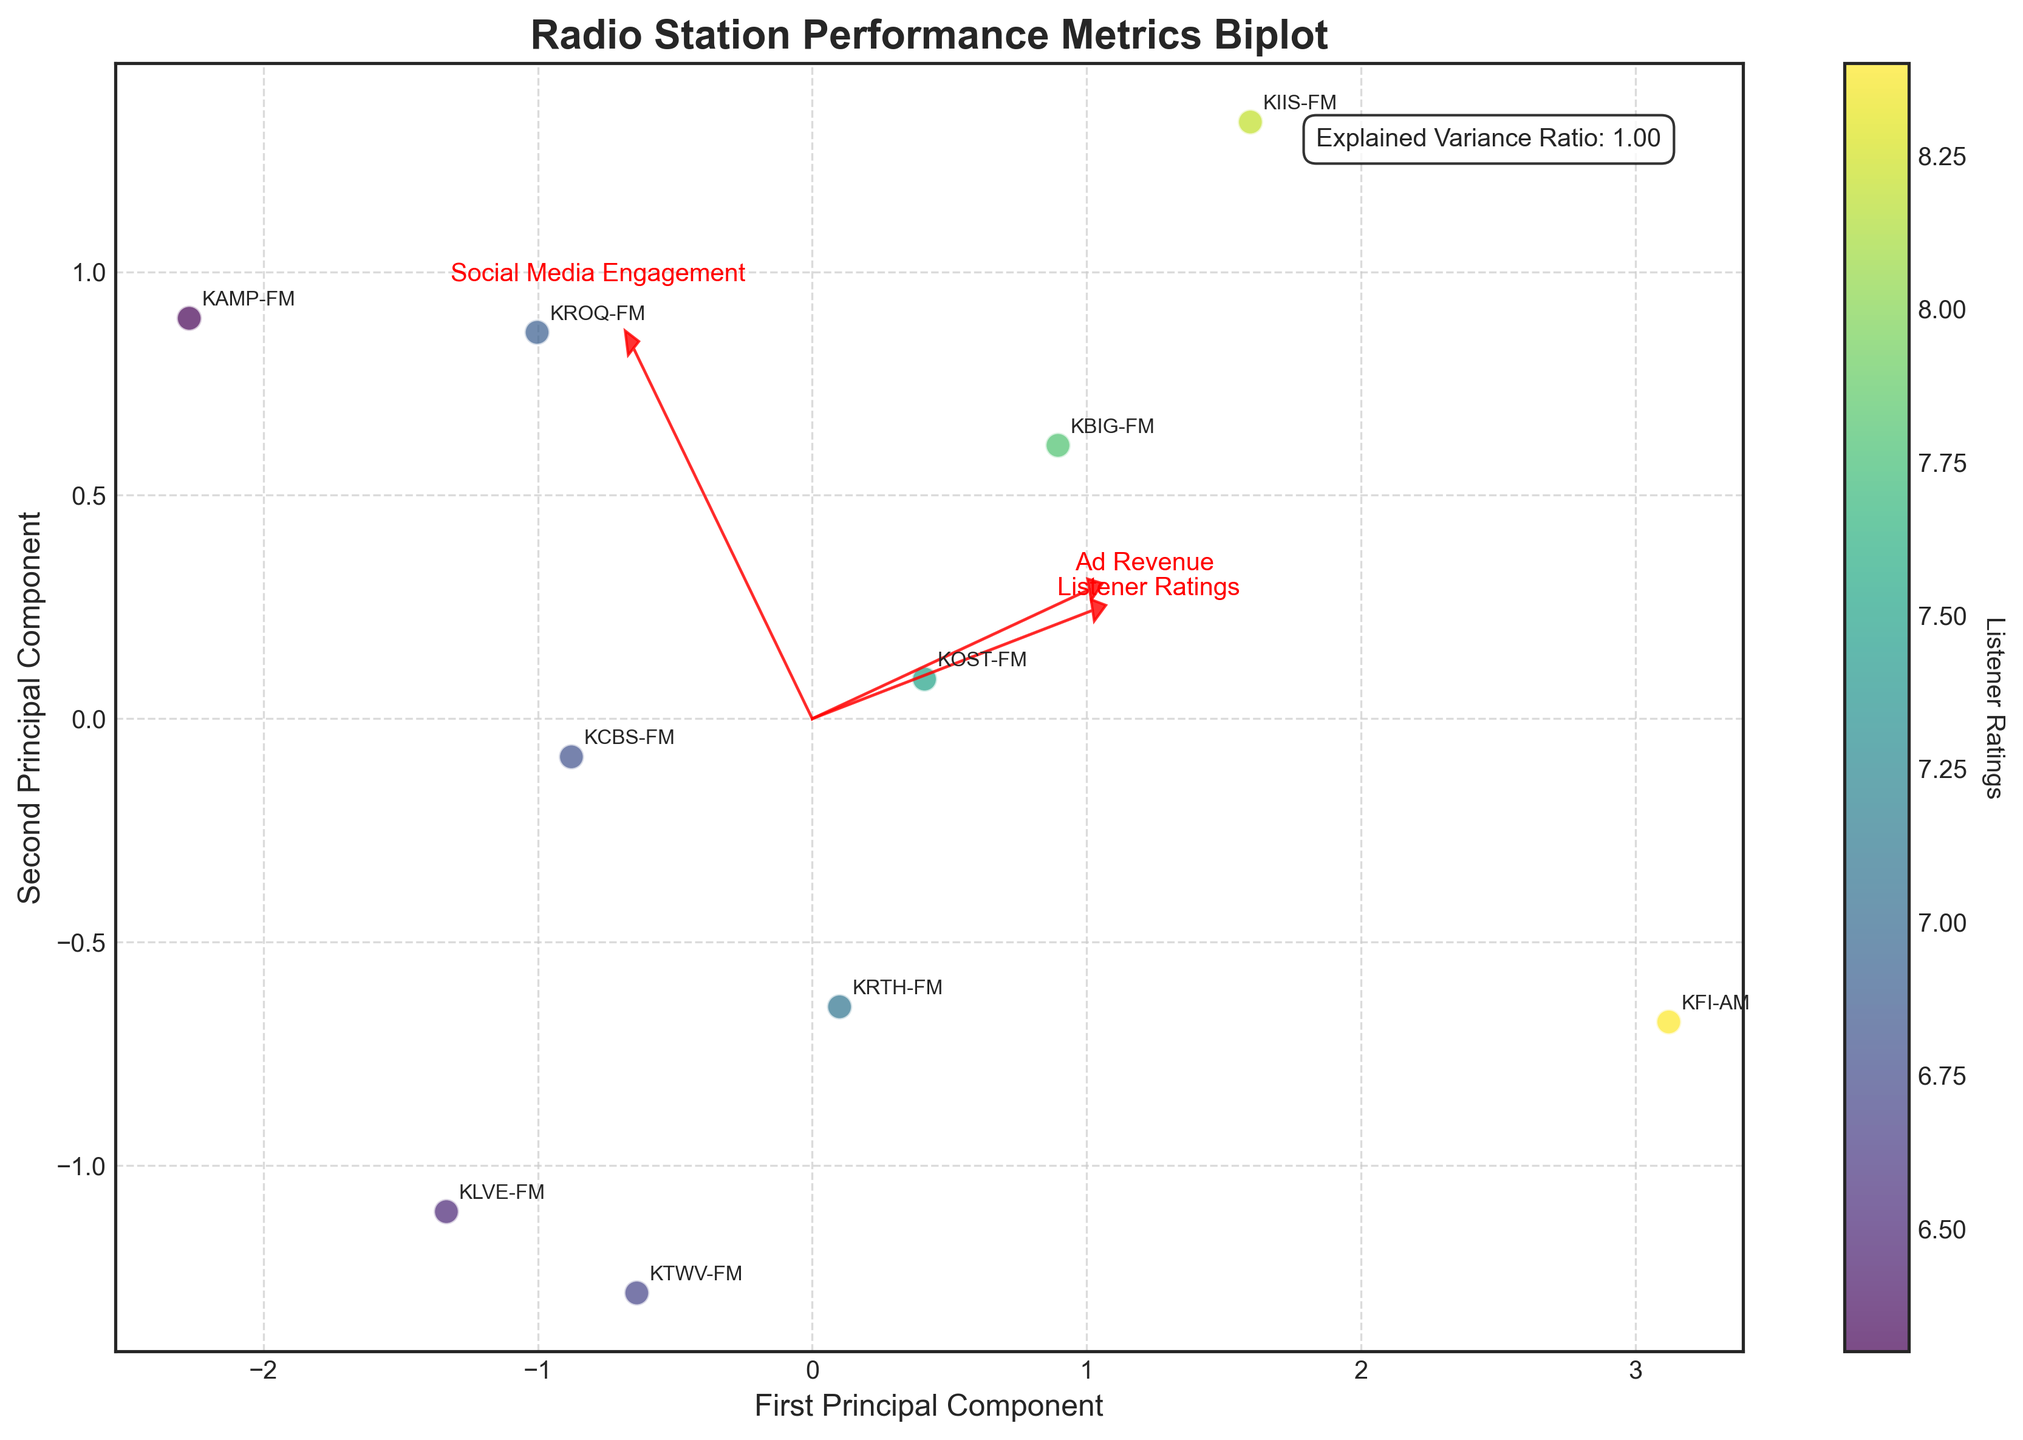What is the title of the figure? The title of the figure is located at the top, and it is usually descriptive of what the figure represents. By looking at the top of the biplot, you can identify it.
Answer: Radio Station Performance Metrics Biplot Which color represents 'Listener Ratings' in the biplot? The color associated with 'Listener Ratings' can be determined by looking at the color bar legend on the right side of the figure. It indicates which color corresponds to 'Listener Ratings'.
Answer: Green to yellow (viridis colormap) How many radio stations are plotted in the biplot? To find the number of radio stations, count the number of data points or labels on the plot. Each station is represented by one point with its respective name annotated.
Answer: 10 Which station has the highest 'Listener Ratings' according to the biplot? By observing the color intensity of the data points in the biplot (where a higher rating corresponds to more yellow), and referring to their labels, you can identify the station with the highest rating.
Answer: KFI-AM What are the two principal components named in the biplot? The names of the principal components can be found along the axes that they label. Typically, they will be labeled 'First Principal Component' and 'Second Principal Component'.
Answer: First Principal Component, Second Principal Component Which station has the highest 'Social Media Engagement'? Observe the points on the biplot and look for the direction of the arrow labeled 'Social Media Engagement'. The point farthest along this axis represents the highest engagement.
Answer: KAMP-FM Between 'KIIS-FM' and 'KOST-FM', which station has higher advertising revenue? By finding the positions of the two stations on the biplot and observing the direction and length of the arrow labeled 'Ad Revenue', you can compare their positions relative to this metric.
Answer: KIIS-FM Could 'KLVE-FM' improve its 'Listener Ratings' while keeping its current position in the biplot? Since 'Listener Ratings' are indicated by the color of the points and not their position, changes in ratings could affect the shading but not the plot position in terms of the principal components.
Answer: Yes Is there a station with notably high 'Ad Revenue' but low 'Social Media Engagement'? Which one? Look for points that lie far along the 'Ad Revenue' arrow but are near the origin or negative for the 'Social Media Engagement' arrow.
Answer: KFI-AM What cumulative percentage of the total variance is explained by the two principal components shown? This information is often noted directly on the figure. Look for the text box that specifies the explained variance ratio near the axes or within the plot.
Answer: 100% 